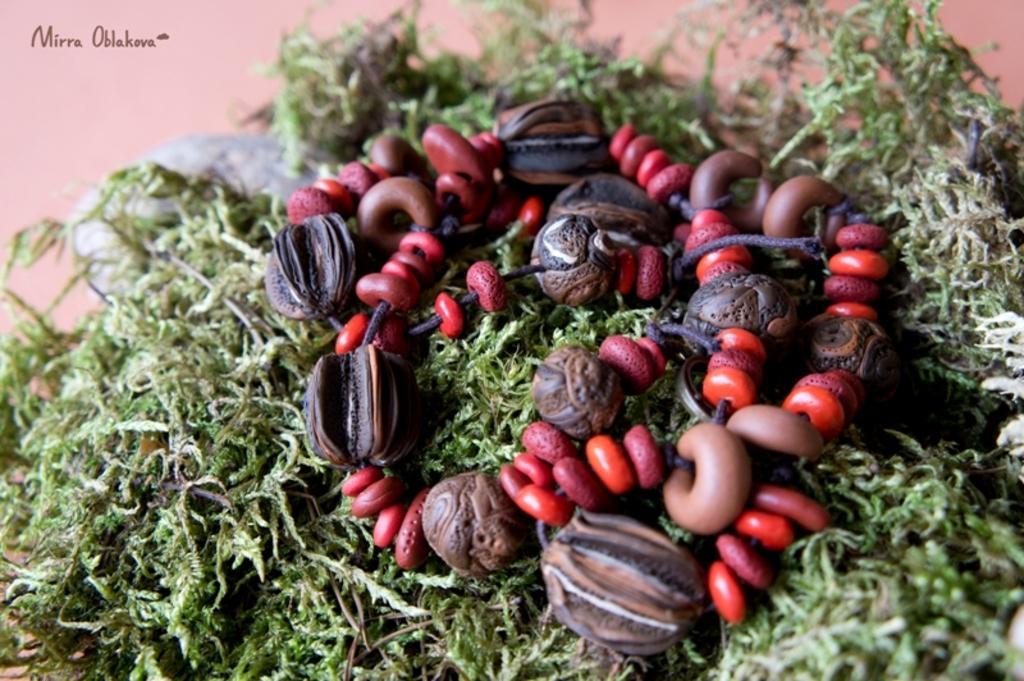Describe this image in one or two sentences. In this image, we can see some leaves. There is a necklace in the middle of the image. There is a text in the top left of the image. 